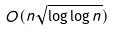<formula> <loc_0><loc_0><loc_500><loc_500>O ( n \sqrt { \log \log n } )</formula> 